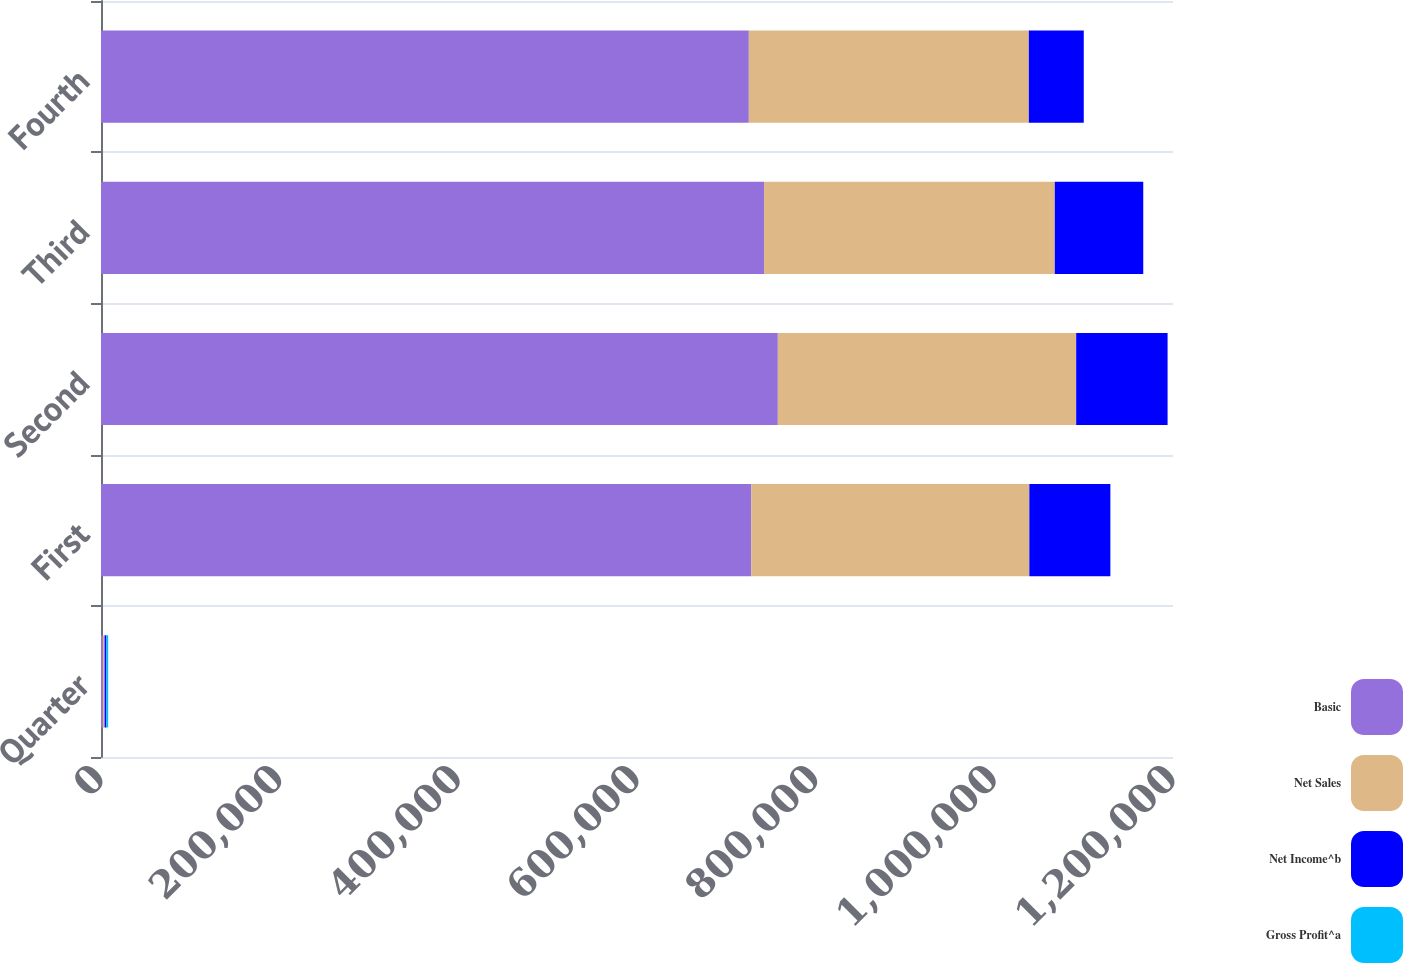Convert chart to OTSL. <chart><loc_0><loc_0><loc_500><loc_500><stacked_bar_chart><ecel><fcel>Quarter<fcel>First<fcel>Second<fcel>Third<fcel>Fourth<nl><fcel>Basic<fcel>2013<fcel>727836<fcel>757635<fcel>742256<fcel>725169<nl><fcel>Net Sales<fcel>2013<fcel>311360<fcel>333986<fcel>325404<fcel>313455<nl><fcel>Net Income^b<fcel>2013<fcel>90697<fcel>102322<fcel>99046<fcel>61479<nl><fcel>Gross Profit^a<fcel>2013<fcel>1.11<fcel>1.25<fcel>1.21<fcel>0.75<nl></chart> 